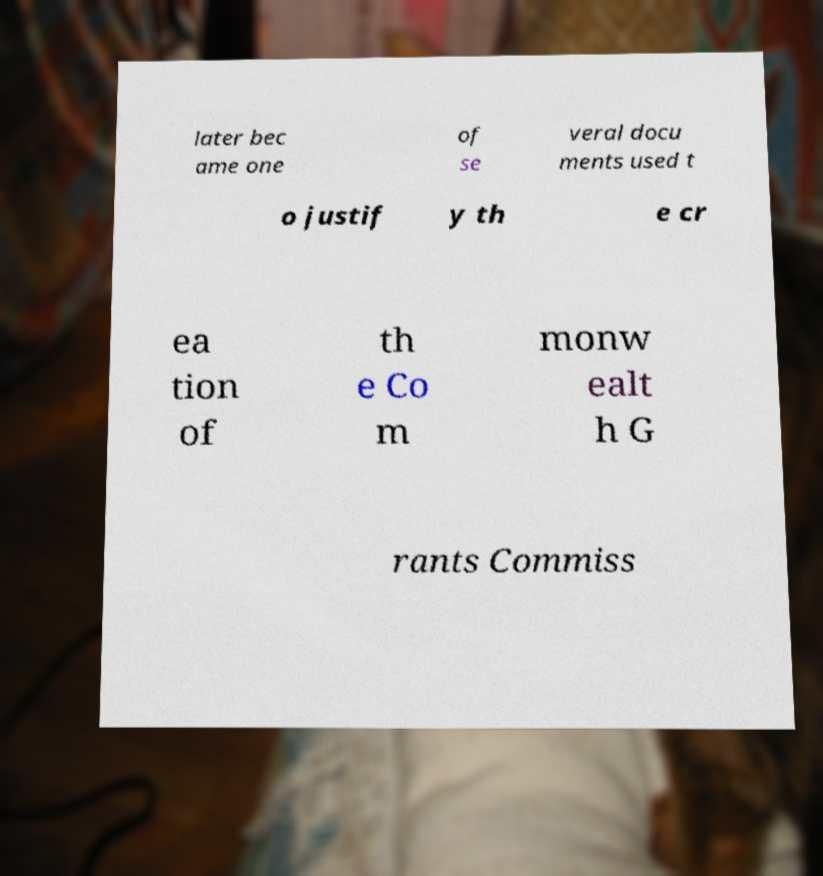What messages or text are displayed in this image? I need them in a readable, typed format. later bec ame one of se veral docu ments used t o justif y th e cr ea tion of th e Co m monw ealt h G rants Commiss 